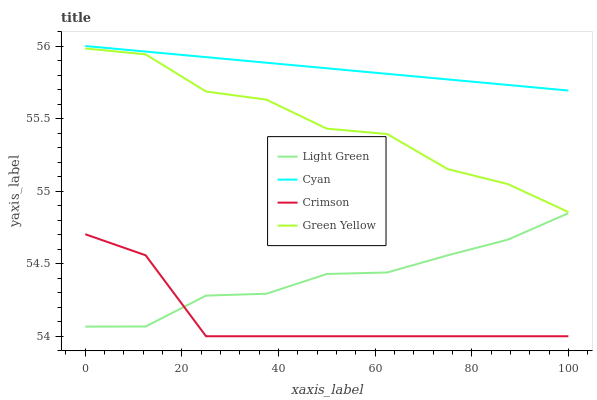Does Crimson have the minimum area under the curve?
Answer yes or no. Yes. Does Cyan have the maximum area under the curve?
Answer yes or no. Yes. Does Green Yellow have the minimum area under the curve?
Answer yes or no. No. Does Green Yellow have the maximum area under the curve?
Answer yes or no. No. Is Cyan the smoothest?
Answer yes or no. Yes. Is Green Yellow the roughest?
Answer yes or no. Yes. Is Green Yellow the smoothest?
Answer yes or no. No. Is Cyan the roughest?
Answer yes or no. No. Does Green Yellow have the lowest value?
Answer yes or no. No. Does Cyan have the highest value?
Answer yes or no. Yes. Does Green Yellow have the highest value?
Answer yes or no. No. Is Light Green less than Green Yellow?
Answer yes or no. Yes. Is Cyan greater than Light Green?
Answer yes or no. Yes. Does Light Green intersect Crimson?
Answer yes or no. Yes. Is Light Green less than Crimson?
Answer yes or no. No. Is Light Green greater than Crimson?
Answer yes or no. No. Does Light Green intersect Green Yellow?
Answer yes or no. No. 